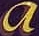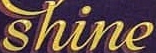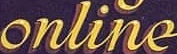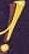Transcribe the words shown in these images in order, separated by a semicolon. a; shine; online; ! 